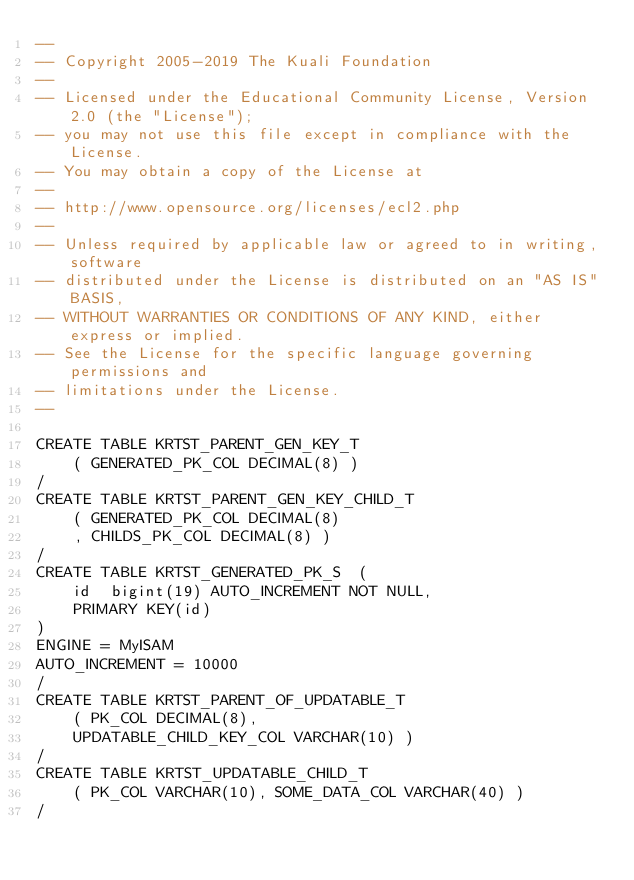Convert code to text. <code><loc_0><loc_0><loc_500><loc_500><_SQL_>--
-- Copyright 2005-2019 The Kuali Foundation
--
-- Licensed under the Educational Community License, Version 2.0 (the "License");
-- you may not use this file except in compliance with the License.
-- You may obtain a copy of the License at
--
-- http://www.opensource.org/licenses/ecl2.php
--
-- Unless required by applicable law or agreed to in writing, software
-- distributed under the License is distributed on an "AS IS" BASIS,
-- WITHOUT WARRANTIES OR CONDITIONS OF ANY KIND, either express or implied.
-- See the License for the specific language governing permissions and
-- limitations under the License.
--

CREATE TABLE KRTST_PARENT_GEN_KEY_T
    ( GENERATED_PK_COL DECIMAL(8) )
/
CREATE TABLE KRTST_PARENT_GEN_KEY_CHILD_T
    ( GENERATED_PK_COL DECIMAL(8)
    , CHILDS_PK_COL DECIMAL(8) )
/
CREATE TABLE KRTST_GENERATED_PK_S  ( 
	id	bigint(19) AUTO_INCREMENT NOT NULL,
	PRIMARY KEY(id)
)
ENGINE = MyISAM
AUTO_INCREMENT = 10000
/
CREATE TABLE KRTST_PARENT_OF_UPDATABLE_T
    ( PK_COL DECIMAL(8),
    UPDATABLE_CHILD_KEY_COL VARCHAR(10) )
/
CREATE TABLE KRTST_UPDATABLE_CHILD_T
    ( PK_COL VARCHAR(10), SOME_DATA_COL VARCHAR(40) )
/
</code> 